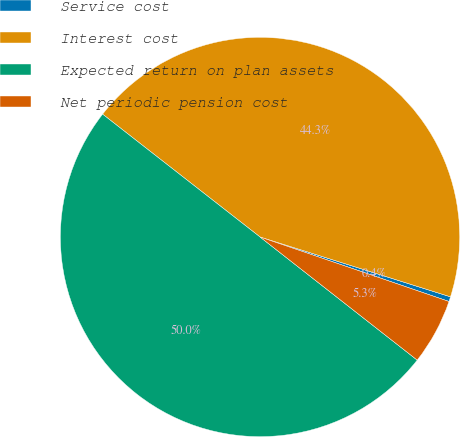Convert chart. <chart><loc_0><loc_0><loc_500><loc_500><pie_chart><fcel>Service cost<fcel>Interest cost<fcel>Expected return on plan assets<fcel>Net periodic pension cost<nl><fcel>0.39%<fcel>44.3%<fcel>49.97%<fcel>5.34%<nl></chart> 